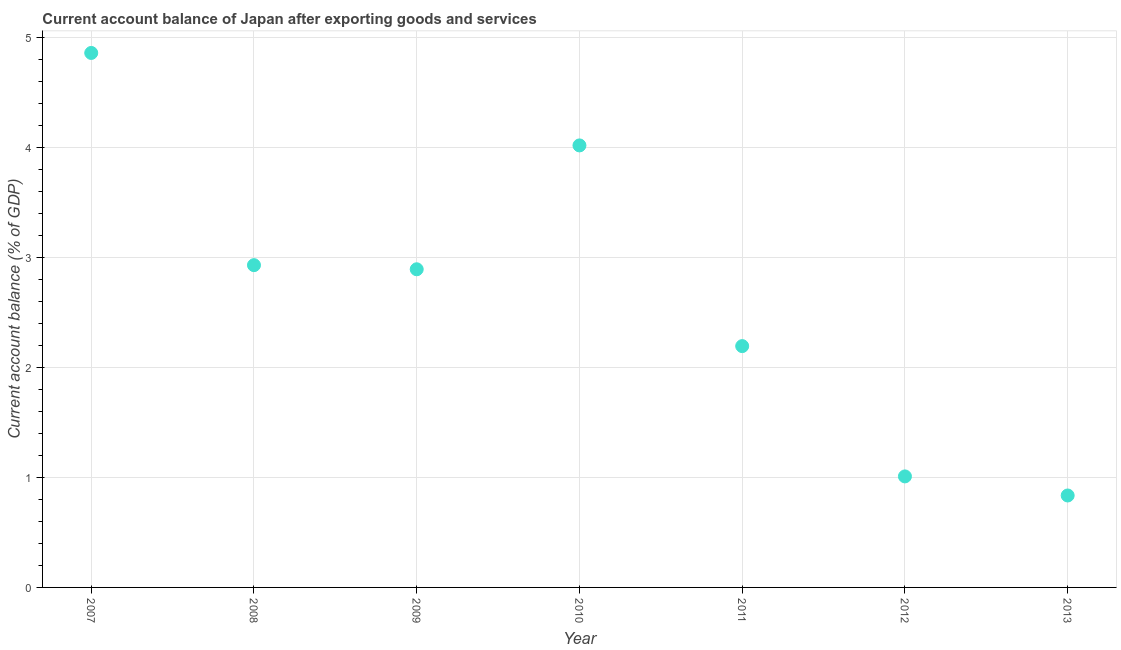What is the current account balance in 2010?
Make the answer very short. 4.02. Across all years, what is the maximum current account balance?
Your answer should be very brief. 4.86. Across all years, what is the minimum current account balance?
Provide a short and direct response. 0.84. In which year was the current account balance minimum?
Give a very brief answer. 2013. What is the sum of the current account balance?
Give a very brief answer. 18.74. What is the difference between the current account balance in 2007 and 2013?
Ensure brevity in your answer.  4.02. What is the average current account balance per year?
Give a very brief answer. 2.68. What is the median current account balance?
Your response must be concise. 2.89. Do a majority of the years between 2007 and 2008 (inclusive) have current account balance greater than 0.8 %?
Your answer should be very brief. Yes. What is the ratio of the current account balance in 2009 to that in 2011?
Provide a succinct answer. 1.32. What is the difference between the highest and the second highest current account balance?
Ensure brevity in your answer.  0.84. What is the difference between the highest and the lowest current account balance?
Your response must be concise. 4.02. Does the current account balance monotonically increase over the years?
Provide a short and direct response. No. How many dotlines are there?
Ensure brevity in your answer.  1. What is the difference between two consecutive major ticks on the Y-axis?
Ensure brevity in your answer.  1. Does the graph contain grids?
Ensure brevity in your answer.  Yes. What is the title of the graph?
Offer a very short reply. Current account balance of Japan after exporting goods and services. What is the label or title of the Y-axis?
Provide a short and direct response. Current account balance (% of GDP). What is the Current account balance (% of GDP) in 2007?
Your answer should be compact. 4.86. What is the Current account balance (% of GDP) in 2008?
Keep it short and to the point. 2.93. What is the Current account balance (% of GDP) in 2009?
Your response must be concise. 2.89. What is the Current account balance (% of GDP) in 2010?
Offer a terse response. 4.02. What is the Current account balance (% of GDP) in 2011?
Your response must be concise. 2.19. What is the Current account balance (% of GDP) in 2012?
Keep it short and to the point. 1.01. What is the Current account balance (% of GDP) in 2013?
Provide a succinct answer. 0.84. What is the difference between the Current account balance (% of GDP) in 2007 and 2008?
Keep it short and to the point. 1.93. What is the difference between the Current account balance (% of GDP) in 2007 and 2009?
Offer a very short reply. 1.97. What is the difference between the Current account balance (% of GDP) in 2007 and 2010?
Offer a very short reply. 0.84. What is the difference between the Current account balance (% of GDP) in 2007 and 2011?
Keep it short and to the point. 2.67. What is the difference between the Current account balance (% of GDP) in 2007 and 2012?
Provide a short and direct response. 3.85. What is the difference between the Current account balance (% of GDP) in 2007 and 2013?
Your answer should be compact. 4.02. What is the difference between the Current account balance (% of GDP) in 2008 and 2009?
Provide a short and direct response. 0.04. What is the difference between the Current account balance (% of GDP) in 2008 and 2010?
Your answer should be very brief. -1.09. What is the difference between the Current account balance (% of GDP) in 2008 and 2011?
Offer a very short reply. 0.74. What is the difference between the Current account balance (% of GDP) in 2008 and 2012?
Your answer should be very brief. 1.92. What is the difference between the Current account balance (% of GDP) in 2008 and 2013?
Give a very brief answer. 2.09. What is the difference between the Current account balance (% of GDP) in 2009 and 2010?
Provide a short and direct response. -1.13. What is the difference between the Current account balance (% of GDP) in 2009 and 2011?
Give a very brief answer. 0.7. What is the difference between the Current account balance (% of GDP) in 2009 and 2012?
Provide a succinct answer. 1.88. What is the difference between the Current account balance (% of GDP) in 2009 and 2013?
Your response must be concise. 2.06. What is the difference between the Current account balance (% of GDP) in 2010 and 2011?
Provide a short and direct response. 1.83. What is the difference between the Current account balance (% of GDP) in 2010 and 2012?
Provide a succinct answer. 3.01. What is the difference between the Current account balance (% of GDP) in 2010 and 2013?
Make the answer very short. 3.18. What is the difference between the Current account balance (% of GDP) in 2011 and 2012?
Your answer should be compact. 1.18. What is the difference between the Current account balance (% of GDP) in 2011 and 2013?
Your answer should be very brief. 1.36. What is the difference between the Current account balance (% of GDP) in 2012 and 2013?
Offer a very short reply. 0.17. What is the ratio of the Current account balance (% of GDP) in 2007 to that in 2008?
Make the answer very short. 1.66. What is the ratio of the Current account balance (% of GDP) in 2007 to that in 2009?
Provide a short and direct response. 1.68. What is the ratio of the Current account balance (% of GDP) in 2007 to that in 2010?
Your answer should be very brief. 1.21. What is the ratio of the Current account balance (% of GDP) in 2007 to that in 2011?
Provide a short and direct response. 2.21. What is the ratio of the Current account balance (% of GDP) in 2007 to that in 2012?
Offer a terse response. 4.81. What is the ratio of the Current account balance (% of GDP) in 2007 to that in 2013?
Provide a succinct answer. 5.81. What is the ratio of the Current account balance (% of GDP) in 2008 to that in 2009?
Keep it short and to the point. 1.01. What is the ratio of the Current account balance (% of GDP) in 2008 to that in 2010?
Offer a terse response. 0.73. What is the ratio of the Current account balance (% of GDP) in 2008 to that in 2011?
Your answer should be compact. 1.34. What is the ratio of the Current account balance (% of GDP) in 2008 to that in 2012?
Your answer should be very brief. 2.9. What is the ratio of the Current account balance (% of GDP) in 2008 to that in 2013?
Make the answer very short. 3.5. What is the ratio of the Current account balance (% of GDP) in 2009 to that in 2010?
Your answer should be very brief. 0.72. What is the ratio of the Current account balance (% of GDP) in 2009 to that in 2011?
Provide a short and direct response. 1.32. What is the ratio of the Current account balance (% of GDP) in 2009 to that in 2012?
Make the answer very short. 2.87. What is the ratio of the Current account balance (% of GDP) in 2009 to that in 2013?
Your response must be concise. 3.46. What is the ratio of the Current account balance (% of GDP) in 2010 to that in 2011?
Offer a terse response. 1.83. What is the ratio of the Current account balance (% of GDP) in 2010 to that in 2012?
Keep it short and to the point. 3.98. What is the ratio of the Current account balance (% of GDP) in 2010 to that in 2013?
Your answer should be compact. 4.81. What is the ratio of the Current account balance (% of GDP) in 2011 to that in 2012?
Offer a terse response. 2.17. What is the ratio of the Current account balance (% of GDP) in 2011 to that in 2013?
Offer a very short reply. 2.62. What is the ratio of the Current account balance (% of GDP) in 2012 to that in 2013?
Provide a short and direct response. 1.21. 